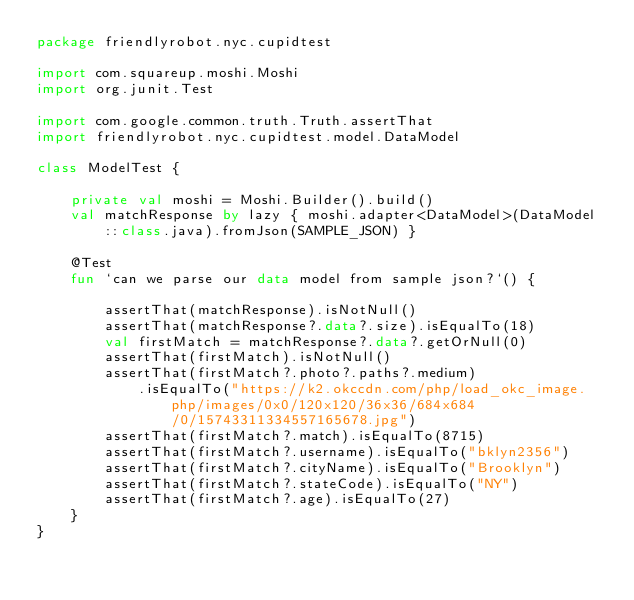<code> <loc_0><loc_0><loc_500><loc_500><_Kotlin_>package friendlyrobot.nyc.cupidtest

import com.squareup.moshi.Moshi
import org.junit.Test

import com.google.common.truth.Truth.assertThat
import friendlyrobot.nyc.cupidtest.model.DataModel

class ModelTest {

    private val moshi = Moshi.Builder().build()
    val matchResponse by lazy { moshi.adapter<DataModel>(DataModel::class.java).fromJson(SAMPLE_JSON) }

    @Test
    fun `can we parse our data model from sample json?`() {

        assertThat(matchResponse).isNotNull()
        assertThat(matchResponse?.data?.size).isEqualTo(18)
        val firstMatch = matchResponse?.data?.getOrNull(0)
        assertThat(firstMatch).isNotNull()
        assertThat(firstMatch?.photo?.paths?.medium)
            .isEqualTo("https://k2.okccdn.com/php/load_okc_image.php/images/0x0/120x120/36x36/684x684/0/15743311334557165678.jpg")
        assertThat(firstMatch?.match).isEqualTo(8715)
        assertThat(firstMatch?.username).isEqualTo("bklyn2356")
        assertThat(firstMatch?.cityName).isEqualTo("Brooklyn")
        assertThat(firstMatch?.stateCode).isEqualTo("NY")
        assertThat(firstMatch?.age).isEqualTo(27)
    }
}
</code> 